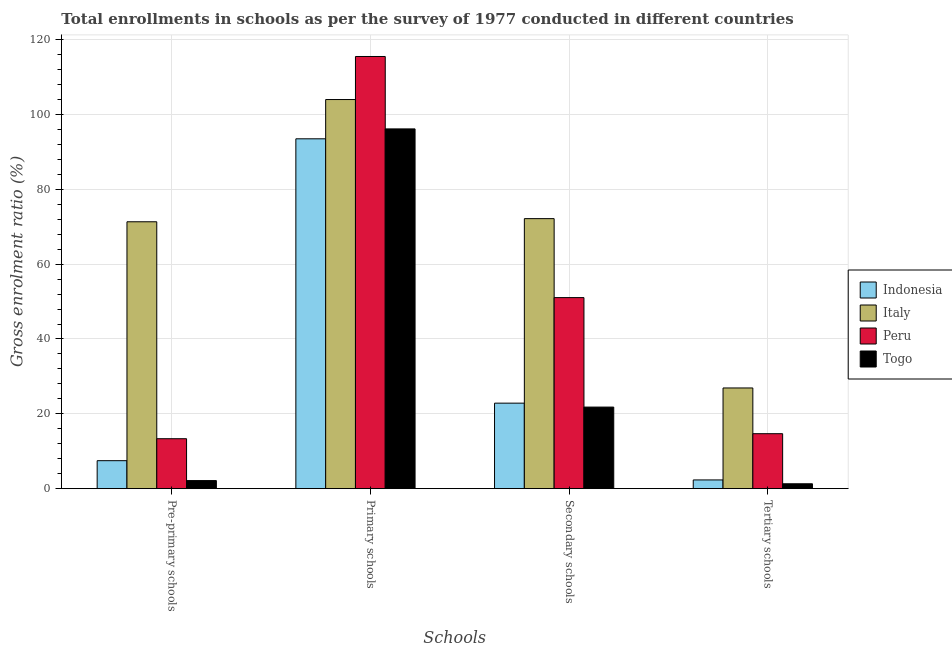How many groups of bars are there?
Your answer should be compact. 4. Are the number of bars per tick equal to the number of legend labels?
Offer a terse response. Yes. Are the number of bars on each tick of the X-axis equal?
Your response must be concise. Yes. How many bars are there on the 4th tick from the left?
Offer a very short reply. 4. How many bars are there on the 4th tick from the right?
Your answer should be compact. 4. What is the label of the 1st group of bars from the left?
Provide a short and direct response. Pre-primary schools. What is the gross enrolment ratio in secondary schools in Peru?
Ensure brevity in your answer.  51.06. Across all countries, what is the maximum gross enrolment ratio in pre-primary schools?
Give a very brief answer. 71.32. Across all countries, what is the minimum gross enrolment ratio in pre-primary schools?
Offer a terse response. 2.16. In which country was the gross enrolment ratio in secondary schools minimum?
Ensure brevity in your answer.  Togo. What is the total gross enrolment ratio in pre-primary schools in the graph?
Provide a succinct answer. 94.32. What is the difference between the gross enrolment ratio in secondary schools in Peru and that in Indonesia?
Your answer should be very brief. 28.2. What is the difference between the gross enrolment ratio in secondary schools in Peru and the gross enrolment ratio in tertiary schools in Italy?
Make the answer very short. 24.14. What is the average gross enrolment ratio in tertiary schools per country?
Provide a short and direct response. 11.31. What is the difference between the gross enrolment ratio in primary schools and gross enrolment ratio in tertiary schools in Indonesia?
Your response must be concise. 91.15. In how many countries, is the gross enrolment ratio in primary schools greater than 24 %?
Your answer should be compact. 4. What is the ratio of the gross enrolment ratio in tertiary schools in Italy to that in Peru?
Keep it short and to the point. 1.83. Is the gross enrolment ratio in tertiary schools in Indonesia less than that in Togo?
Offer a terse response. No. Is the difference between the gross enrolment ratio in primary schools in Italy and Togo greater than the difference between the gross enrolment ratio in secondary schools in Italy and Togo?
Provide a succinct answer. No. What is the difference between the highest and the second highest gross enrolment ratio in primary schools?
Ensure brevity in your answer.  11.51. What is the difference between the highest and the lowest gross enrolment ratio in secondary schools?
Keep it short and to the point. 50.35. Is the sum of the gross enrolment ratio in tertiary schools in Italy and Indonesia greater than the maximum gross enrolment ratio in primary schools across all countries?
Provide a short and direct response. No. What does the 4th bar from the left in Secondary schools represents?
Give a very brief answer. Togo. Is it the case that in every country, the sum of the gross enrolment ratio in pre-primary schools and gross enrolment ratio in primary schools is greater than the gross enrolment ratio in secondary schools?
Your response must be concise. Yes. How many bars are there?
Your answer should be very brief. 16. Are all the bars in the graph horizontal?
Your answer should be very brief. No. How many countries are there in the graph?
Provide a short and direct response. 4. What is the difference between two consecutive major ticks on the Y-axis?
Keep it short and to the point. 20. Does the graph contain grids?
Give a very brief answer. Yes. How many legend labels are there?
Your answer should be very brief. 4. How are the legend labels stacked?
Offer a terse response. Vertical. What is the title of the graph?
Keep it short and to the point. Total enrollments in schools as per the survey of 1977 conducted in different countries. Does "New Caledonia" appear as one of the legend labels in the graph?
Offer a terse response. No. What is the label or title of the X-axis?
Keep it short and to the point. Schools. What is the Gross enrolment ratio (%) in Indonesia in Pre-primary schools?
Provide a succinct answer. 7.48. What is the Gross enrolment ratio (%) in Italy in Pre-primary schools?
Provide a short and direct response. 71.32. What is the Gross enrolment ratio (%) of Peru in Pre-primary schools?
Keep it short and to the point. 13.35. What is the Gross enrolment ratio (%) of Togo in Pre-primary schools?
Provide a succinct answer. 2.16. What is the Gross enrolment ratio (%) of Indonesia in Primary schools?
Your answer should be very brief. 93.49. What is the Gross enrolment ratio (%) in Italy in Primary schools?
Offer a terse response. 103.98. What is the Gross enrolment ratio (%) in Peru in Primary schools?
Offer a very short reply. 115.49. What is the Gross enrolment ratio (%) in Togo in Primary schools?
Offer a very short reply. 96.14. What is the Gross enrolment ratio (%) of Indonesia in Secondary schools?
Give a very brief answer. 22.86. What is the Gross enrolment ratio (%) in Italy in Secondary schools?
Ensure brevity in your answer.  72.16. What is the Gross enrolment ratio (%) in Peru in Secondary schools?
Keep it short and to the point. 51.06. What is the Gross enrolment ratio (%) of Togo in Secondary schools?
Provide a short and direct response. 21.8. What is the Gross enrolment ratio (%) of Indonesia in Tertiary schools?
Give a very brief answer. 2.34. What is the Gross enrolment ratio (%) in Italy in Tertiary schools?
Offer a very short reply. 26.91. What is the Gross enrolment ratio (%) in Peru in Tertiary schools?
Provide a short and direct response. 14.69. What is the Gross enrolment ratio (%) in Togo in Tertiary schools?
Ensure brevity in your answer.  1.31. Across all Schools, what is the maximum Gross enrolment ratio (%) in Indonesia?
Offer a terse response. 93.49. Across all Schools, what is the maximum Gross enrolment ratio (%) in Italy?
Provide a succinct answer. 103.98. Across all Schools, what is the maximum Gross enrolment ratio (%) of Peru?
Offer a terse response. 115.49. Across all Schools, what is the maximum Gross enrolment ratio (%) in Togo?
Provide a succinct answer. 96.14. Across all Schools, what is the minimum Gross enrolment ratio (%) of Indonesia?
Keep it short and to the point. 2.34. Across all Schools, what is the minimum Gross enrolment ratio (%) in Italy?
Give a very brief answer. 26.91. Across all Schools, what is the minimum Gross enrolment ratio (%) in Peru?
Offer a terse response. 13.35. Across all Schools, what is the minimum Gross enrolment ratio (%) in Togo?
Provide a short and direct response. 1.31. What is the total Gross enrolment ratio (%) in Indonesia in the graph?
Offer a very short reply. 126.17. What is the total Gross enrolment ratio (%) in Italy in the graph?
Your answer should be compact. 274.38. What is the total Gross enrolment ratio (%) of Peru in the graph?
Offer a very short reply. 194.59. What is the total Gross enrolment ratio (%) in Togo in the graph?
Keep it short and to the point. 121.41. What is the difference between the Gross enrolment ratio (%) in Indonesia in Pre-primary schools and that in Primary schools?
Provide a short and direct response. -86.01. What is the difference between the Gross enrolment ratio (%) in Italy in Pre-primary schools and that in Primary schools?
Offer a very short reply. -32.66. What is the difference between the Gross enrolment ratio (%) in Peru in Pre-primary schools and that in Primary schools?
Make the answer very short. -102.14. What is the difference between the Gross enrolment ratio (%) of Togo in Pre-primary schools and that in Primary schools?
Make the answer very short. -93.98. What is the difference between the Gross enrolment ratio (%) in Indonesia in Pre-primary schools and that in Secondary schools?
Offer a very short reply. -15.37. What is the difference between the Gross enrolment ratio (%) in Italy in Pre-primary schools and that in Secondary schools?
Give a very brief answer. -0.84. What is the difference between the Gross enrolment ratio (%) in Peru in Pre-primary schools and that in Secondary schools?
Offer a very short reply. -37.71. What is the difference between the Gross enrolment ratio (%) of Togo in Pre-primary schools and that in Secondary schools?
Keep it short and to the point. -19.64. What is the difference between the Gross enrolment ratio (%) in Indonesia in Pre-primary schools and that in Tertiary schools?
Make the answer very short. 5.15. What is the difference between the Gross enrolment ratio (%) in Italy in Pre-primary schools and that in Tertiary schools?
Your answer should be very brief. 44.41. What is the difference between the Gross enrolment ratio (%) in Peru in Pre-primary schools and that in Tertiary schools?
Give a very brief answer. -1.34. What is the difference between the Gross enrolment ratio (%) in Togo in Pre-primary schools and that in Tertiary schools?
Your response must be concise. 0.85. What is the difference between the Gross enrolment ratio (%) of Indonesia in Primary schools and that in Secondary schools?
Provide a succinct answer. 70.64. What is the difference between the Gross enrolment ratio (%) in Italy in Primary schools and that in Secondary schools?
Your response must be concise. 31.82. What is the difference between the Gross enrolment ratio (%) in Peru in Primary schools and that in Secondary schools?
Your answer should be compact. 64.43. What is the difference between the Gross enrolment ratio (%) of Togo in Primary schools and that in Secondary schools?
Give a very brief answer. 74.33. What is the difference between the Gross enrolment ratio (%) of Indonesia in Primary schools and that in Tertiary schools?
Keep it short and to the point. 91.15. What is the difference between the Gross enrolment ratio (%) of Italy in Primary schools and that in Tertiary schools?
Your response must be concise. 77.07. What is the difference between the Gross enrolment ratio (%) in Peru in Primary schools and that in Tertiary schools?
Your answer should be very brief. 100.8. What is the difference between the Gross enrolment ratio (%) of Togo in Primary schools and that in Tertiary schools?
Give a very brief answer. 94.83. What is the difference between the Gross enrolment ratio (%) in Indonesia in Secondary schools and that in Tertiary schools?
Provide a short and direct response. 20.52. What is the difference between the Gross enrolment ratio (%) of Italy in Secondary schools and that in Tertiary schools?
Keep it short and to the point. 45.25. What is the difference between the Gross enrolment ratio (%) of Peru in Secondary schools and that in Tertiary schools?
Provide a short and direct response. 36.36. What is the difference between the Gross enrolment ratio (%) in Togo in Secondary schools and that in Tertiary schools?
Make the answer very short. 20.49. What is the difference between the Gross enrolment ratio (%) in Indonesia in Pre-primary schools and the Gross enrolment ratio (%) in Italy in Primary schools?
Offer a terse response. -96.5. What is the difference between the Gross enrolment ratio (%) of Indonesia in Pre-primary schools and the Gross enrolment ratio (%) of Peru in Primary schools?
Your answer should be compact. -108.01. What is the difference between the Gross enrolment ratio (%) in Indonesia in Pre-primary schools and the Gross enrolment ratio (%) in Togo in Primary schools?
Your response must be concise. -88.65. What is the difference between the Gross enrolment ratio (%) in Italy in Pre-primary schools and the Gross enrolment ratio (%) in Peru in Primary schools?
Give a very brief answer. -44.17. What is the difference between the Gross enrolment ratio (%) in Italy in Pre-primary schools and the Gross enrolment ratio (%) in Togo in Primary schools?
Offer a terse response. -24.81. What is the difference between the Gross enrolment ratio (%) in Peru in Pre-primary schools and the Gross enrolment ratio (%) in Togo in Primary schools?
Your answer should be very brief. -82.79. What is the difference between the Gross enrolment ratio (%) of Indonesia in Pre-primary schools and the Gross enrolment ratio (%) of Italy in Secondary schools?
Make the answer very short. -64.68. What is the difference between the Gross enrolment ratio (%) of Indonesia in Pre-primary schools and the Gross enrolment ratio (%) of Peru in Secondary schools?
Provide a short and direct response. -43.57. What is the difference between the Gross enrolment ratio (%) of Indonesia in Pre-primary schools and the Gross enrolment ratio (%) of Togo in Secondary schools?
Your response must be concise. -14.32. What is the difference between the Gross enrolment ratio (%) in Italy in Pre-primary schools and the Gross enrolment ratio (%) in Peru in Secondary schools?
Your response must be concise. 20.27. What is the difference between the Gross enrolment ratio (%) of Italy in Pre-primary schools and the Gross enrolment ratio (%) of Togo in Secondary schools?
Provide a succinct answer. 49.52. What is the difference between the Gross enrolment ratio (%) in Peru in Pre-primary schools and the Gross enrolment ratio (%) in Togo in Secondary schools?
Give a very brief answer. -8.45. What is the difference between the Gross enrolment ratio (%) in Indonesia in Pre-primary schools and the Gross enrolment ratio (%) in Italy in Tertiary schools?
Make the answer very short. -19.43. What is the difference between the Gross enrolment ratio (%) of Indonesia in Pre-primary schools and the Gross enrolment ratio (%) of Peru in Tertiary schools?
Keep it short and to the point. -7.21. What is the difference between the Gross enrolment ratio (%) of Indonesia in Pre-primary schools and the Gross enrolment ratio (%) of Togo in Tertiary schools?
Keep it short and to the point. 6.17. What is the difference between the Gross enrolment ratio (%) of Italy in Pre-primary schools and the Gross enrolment ratio (%) of Peru in Tertiary schools?
Offer a very short reply. 56.63. What is the difference between the Gross enrolment ratio (%) of Italy in Pre-primary schools and the Gross enrolment ratio (%) of Togo in Tertiary schools?
Ensure brevity in your answer.  70.01. What is the difference between the Gross enrolment ratio (%) in Peru in Pre-primary schools and the Gross enrolment ratio (%) in Togo in Tertiary schools?
Give a very brief answer. 12.04. What is the difference between the Gross enrolment ratio (%) of Indonesia in Primary schools and the Gross enrolment ratio (%) of Italy in Secondary schools?
Provide a short and direct response. 21.33. What is the difference between the Gross enrolment ratio (%) in Indonesia in Primary schools and the Gross enrolment ratio (%) in Peru in Secondary schools?
Provide a succinct answer. 42.43. What is the difference between the Gross enrolment ratio (%) in Indonesia in Primary schools and the Gross enrolment ratio (%) in Togo in Secondary schools?
Keep it short and to the point. 71.69. What is the difference between the Gross enrolment ratio (%) of Italy in Primary schools and the Gross enrolment ratio (%) of Peru in Secondary schools?
Your answer should be very brief. 52.93. What is the difference between the Gross enrolment ratio (%) in Italy in Primary schools and the Gross enrolment ratio (%) in Togo in Secondary schools?
Give a very brief answer. 82.18. What is the difference between the Gross enrolment ratio (%) of Peru in Primary schools and the Gross enrolment ratio (%) of Togo in Secondary schools?
Your answer should be compact. 93.68. What is the difference between the Gross enrolment ratio (%) of Indonesia in Primary schools and the Gross enrolment ratio (%) of Italy in Tertiary schools?
Your response must be concise. 66.58. What is the difference between the Gross enrolment ratio (%) in Indonesia in Primary schools and the Gross enrolment ratio (%) in Peru in Tertiary schools?
Your response must be concise. 78.8. What is the difference between the Gross enrolment ratio (%) in Indonesia in Primary schools and the Gross enrolment ratio (%) in Togo in Tertiary schools?
Ensure brevity in your answer.  92.18. What is the difference between the Gross enrolment ratio (%) in Italy in Primary schools and the Gross enrolment ratio (%) in Peru in Tertiary schools?
Provide a succinct answer. 89.29. What is the difference between the Gross enrolment ratio (%) in Italy in Primary schools and the Gross enrolment ratio (%) in Togo in Tertiary schools?
Give a very brief answer. 102.67. What is the difference between the Gross enrolment ratio (%) in Peru in Primary schools and the Gross enrolment ratio (%) in Togo in Tertiary schools?
Offer a terse response. 114.18. What is the difference between the Gross enrolment ratio (%) of Indonesia in Secondary schools and the Gross enrolment ratio (%) of Italy in Tertiary schools?
Your response must be concise. -4.06. What is the difference between the Gross enrolment ratio (%) of Indonesia in Secondary schools and the Gross enrolment ratio (%) of Peru in Tertiary schools?
Offer a very short reply. 8.16. What is the difference between the Gross enrolment ratio (%) of Indonesia in Secondary schools and the Gross enrolment ratio (%) of Togo in Tertiary schools?
Ensure brevity in your answer.  21.55. What is the difference between the Gross enrolment ratio (%) in Italy in Secondary schools and the Gross enrolment ratio (%) in Peru in Tertiary schools?
Your answer should be compact. 57.47. What is the difference between the Gross enrolment ratio (%) in Italy in Secondary schools and the Gross enrolment ratio (%) in Togo in Tertiary schools?
Offer a terse response. 70.85. What is the difference between the Gross enrolment ratio (%) in Peru in Secondary schools and the Gross enrolment ratio (%) in Togo in Tertiary schools?
Ensure brevity in your answer.  49.75. What is the average Gross enrolment ratio (%) of Indonesia per Schools?
Give a very brief answer. 31.54. What is the average Gross enrolment ratio (%) of Italy per Schools?
Offer a terse response. 68.59. What is the average Gross enrolment ratio (%) of Peru per Schools?
Offer a terse response. 48.65. What is the average Gross enrolment ratio (%) of Togo per Schools?
Your answer should be very brief. 30.35. What is the difference between the Gross enrolment ratio (%) of Indonesia and Gross enrolment ratio (%) of Italy in Pre-primary schools?
Offer a terse response. -63.84. What is the difference between the Gross enrolment ratio (%) of Indonesia and Gross enrolment ratio (%) of Peru in Pre-primary schools?
Keep it short and to the point. -5.87. What is the difference between the Gross enrolment ratio (%) in Indonesia and Gross enrolment ratio (%) in Togo in Pre-primary schools?
Keep it short and to the point. 5.32. What is the difference between the Gross enrolment ratio (%) of Italy and Gross enrolment ratio (%) of Peru in Pre-primary schools?
Provide a short and direct response. 57.97. What is the difference between the Gross enrolment ratio (%) in Italy and Gross enrolment ratio (%) in Togo in Pre-primary schools?
Your answer should be compact. 69.16. What is the difference between the Gross enrolment ratio (%) of Peru and Gross enrolment ratio (%) of Togo in Pre-primary schools?
Provide a short and direct response. 11.19. What is the difference between the Gross enrolment ratio (%) of Indonesia and Gross enrolment ratio (%) of Italy in Primary schools?
Give a very brief answer. -10.49. What is the difference between the Gross enrolment ratio (%) of Indonesia and Gross enrolment ratio (%) of Peru in Primary schools?
Your answer should be very brief. -22. What is the difference between the Gross enrolment ratio (%) in Indonesia and Gross enrolment ratio (%) in Togo in Primary schools?
Provide a succinct answer. -2.65. What is the difference between the Gross enrolment ratio (%) in Italy and Gross enrolment ratio (%) in Peru in Primary schools?
Provide a short and direct response. -11.51. What is the difference between the Gross enrolment ratio (%) of Italy and Gross enrolment ratio (%) of Togo in Primary schools?
Provide a short and direct response. 7.85. What is the difference between the Gross enrolment ratio (%) in Peru and Gross enrolment ratio (%) in Togo in Primary schools?
Offer a very short reply. 19.35. What is the difference between the Gross enrolment ratio (%) in Indonesia and Gross enrolment ratio (%) in Italy in Secondary schools?
Keep it short and to the point. -49.3. What is the difference between the Gross enrolment ratio (%) in Indonesia and Gross enrolment ratio (%) in Peru in Secondary schools?
Make the answer very short. -28.2. What is the difference between the Gross enrolment ratio (%) of Indonesia and Gross enrolment ratio (%) of Togo in Secondary schools?
Offer a terse response. 1.05. What is the difference between the Gross enrolment ratio (%) of Italy and Gross enrolment ratio (%) of Peru in Secondary schools?
Offer a very short reply. 21.1. What is the difference between the Gross enrolment ratio (%) of Italy and Gross enrolment ratio (%) of Togo in Secondary schools?
Offer a very short reply. 50.35. What is the difference between the Gross enrolment ratio (%) of Peru and Gross enrolment ratio (%) of Togo in Secondary schools?
Your response must be concise. 29.25. What is the difference between the Gross enrolment ratio (%) of Indonesia and Gross enrolment ratio (%) of Italy in Tertiary schools?
Keep it short and to the point. -24.58. What is the difference between the Gross enrolment ratio (%) of Indonesia and Gross enrolment ratio (%) of Peru in Tertiary schools?
Your response must be concise. -12.36. What is the difference between the Gross enrolment ratio (%) in Indonesia and Gross enrolment ratio (%) in Togo in Tertiary schools?
Your answer should be very brief. 1.03. What is the difference between the Gross enrolment ratio (%) in Italy and Gross enrolment ratio (%) in Peru in Tertiary schools?
Give a very brief answer. 12.22. What is the difference between the Gross enrolment ratio (%) in Italy and Gross enrolment ratio (%) in Togo in Tertiary schools?
Your answer should be very brief. 25.6. What is the difference between the Gross enrolment ratio (%) of Peru and Gross enrolment ratio (%) of Togo in Tertiary schools?
Offer a terse response. 13.38. What is the ratio of the Gross enrolment ratio (%) in Italy in Pre-primary schools to that in Primary schools?
Keep it short and to the point. 0.69. What is the ratio of the Gross enrolment ratio (%) of Peru in Pre-primary schools to that in Primary schools?
Your answer should be compact. 0.12. What is the ratio of the Gross enrolment ratio (%) in Togo in Pre-primary schools to that in Primary schools?
Provide a short and direct response. 0.02. What is the ratio of the Gross enrolment ratio (%) in Indonesia in Pre-primary schools to that in Secondary schools?
Provide a short and direct response. 0.33. What is the ratio of the Gross enrolment ratio (%) in Italy in Pre-primary schools to that in Secondary schools?
Give a very brief answer. 0.99. What is the ratio of the Gross enrolment ratio (%) in Peru in Pre-primary schools to that in Secondary schools?
Provide a succinct answer. 0.26. What is the ratio of the Gross enrolment ratio (%) in Togo in Pre-primary schools to that in Secondary schools?
Your answer should be very brief. 0.1. What is the ratio of the Gross enrolment ratio (%) in Indonesia in Pre-primary schools to that in Tertiary schools?
Provide a short and direct response. 3.2. What is the ratio of the Gross enrolment ratio (%) in Italy in Pre-primary schools to that in Tertiary schools?
Make the answer very short. 2.65. What is the ratio of the Gross enrolment ratio (%) in Peru in Pre-primary schools to that in Tertiary schools?
Make the answer very short. 0.91. What is the ratio of the Gross enrolment ratio (%) in Togo in Pre-primary schools to that in Tertiary schools?
Keep it short and to the point. 1.65. What is the ratio of the Gross enrolment ratio (%) of Indonesia in Primary schools to that in Secondary schools?
Make the answer very short. 4.09. What is the ratio of the Gross enrolment ratio (%) in Italy in Primary schools to that in Secondary schools?
Give a very brief answer. 1.44. What is the ratio of the Gross enrolment ratio (%) of Peru in Primary schools to that in Secondary schools?
Keep it short and to the point. 2.26. What is the ratio of the Gross enrolment ratio (%) of Togo in Primary schools to that in Secondary schools?
Make the answer very short. 4.41. What is the ratio of the Gross enrolment ratio (%) in Indonesia in Primary schools to that in Tertiary schools?
Your answer should be compact. 40.02. What is the ratio of the Gross enrolment ratio (%) in Italy in Primary schools to that in Tertiary schools?
Ensure brevity in your answer.  3.86. What is the ratio of the Gross enrolment ratio (%) in Peru in Primary schools to that in Tertiary schools?
Provide a short and direct response. 7.86. What is the ratio of the Gross enrolment ratio (%) of Togo in Primary schools to that in Tertiary schools?
Your answer should be very brief. 73.4. What is the ratio of the Gross enrolment ratio (%) of Indonesia in Secondary schools to that in Tertiary schools?
Keep it short and to the point. 9.78. What is the ratio of the Gross enrolment ratio (%) of Italy in Secondary schools to that in Tertiary schools?
Offer a terse response. 2.68. What is the ratio of the Gross enrolment ratio (%) of Peru in Secondary schools to that in Tertiary schools?
Your response must be concise. 3.48. What is the ratio of the Gross enrolment ratio (%) in Togo in Secondary schools to that in Tertiary schools?
Make the answer very short. 16.65. What is the difference between the highest and the second highest Gross enrolment ratio (%) of Indonesia?
Make the answer very short. 70.64. What is the difference between the highest and the second highest Gross enrolment ratio (%) of Italy?
Provide a succinct answer. 31.82. What is the difference between the highest and the second highest Gross enrolment ratio (%) of Peru?
Make the answer very short. 64.43. What is the difference between the highest and the second highest Gross enrolment ratio (%) in Togo?
Offer a terse response. 74.33. What is the difference between the highest and the lowest Gross enrolment ratio (%) of Indonesia?
Offer a very short reply. 91.15. What is the difference between the highest and the lowest Gross enrolment ratio (%) of Italy?
Your answer should be very brief. 77.07. What is the difference between the highest and the lowest Gross enrolment ratio (%) of Peru?
Your answer should be compact. 102.14. What is the difference between the highest and the lowest Gross enrolment ratio (%) in Togo?
Your answer should be very brief. 94.83. 